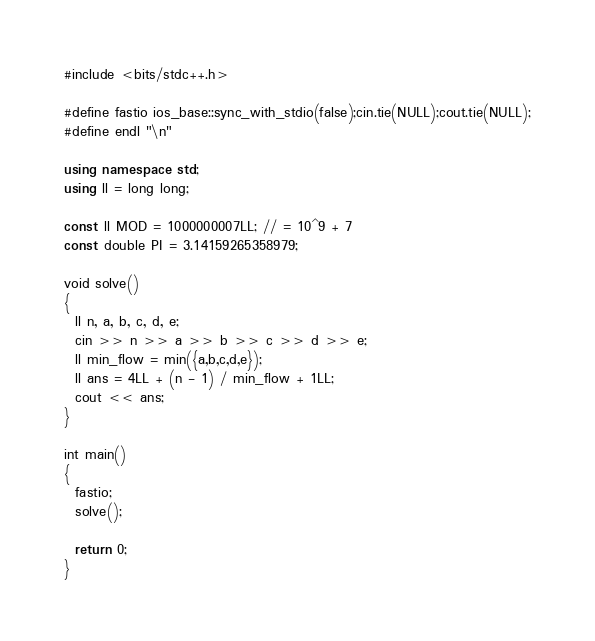<code> <loc_0><loc_0><loc_500><loc_500><_C++_>#include <bits/stdc++.h>

#define fastio ios_base::sync_with_stdio(false);cin.tie(NULL);cout.tie(NULL);
#define endl "\n"

using namespace std;
using ll = long long;

const ll MOD = 1000000007LL; // = 10^9 + 7
const double PI = 3.14159265358979;

void solve()
{
  ll n, a, b, c, d, e;
  cin >> n >> a >> b >> c >> d >> e;
  ll min_flow = min({a,b,c,d,e});
  ll ans = 4LL + (n - 1) / min_flow + 1LL;
  cout << ans;
}

int main()
{
  fastio;
  solve();

  return 0;
}</code> 